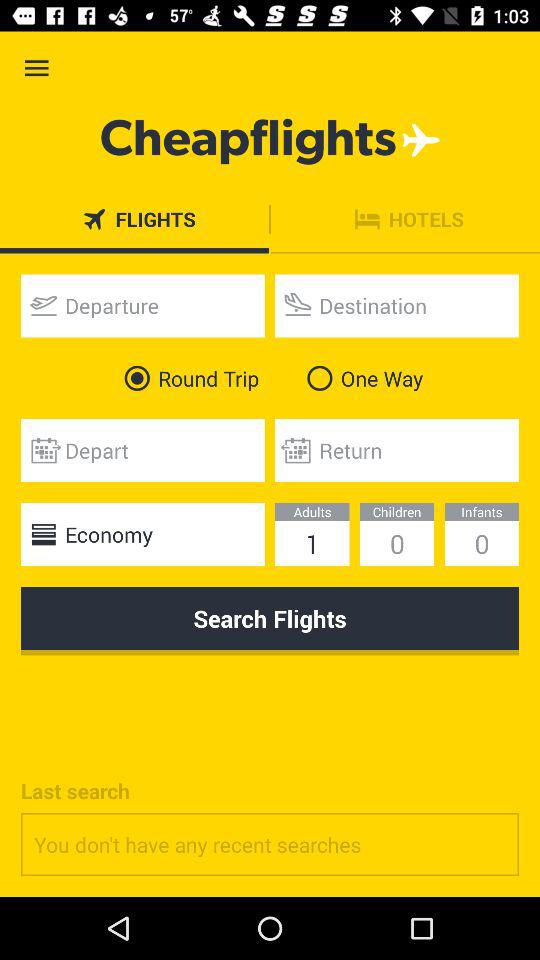How many more adults than children are in the search?
Answer the question using a single word or phrase. 1 